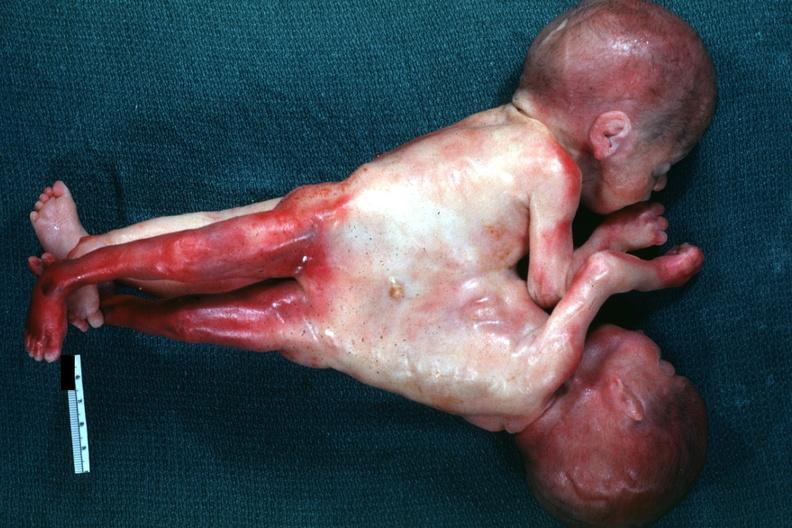s very good example joined abdomen and lower chest anterior?
Answer the question using a single word or phrase. Yes 